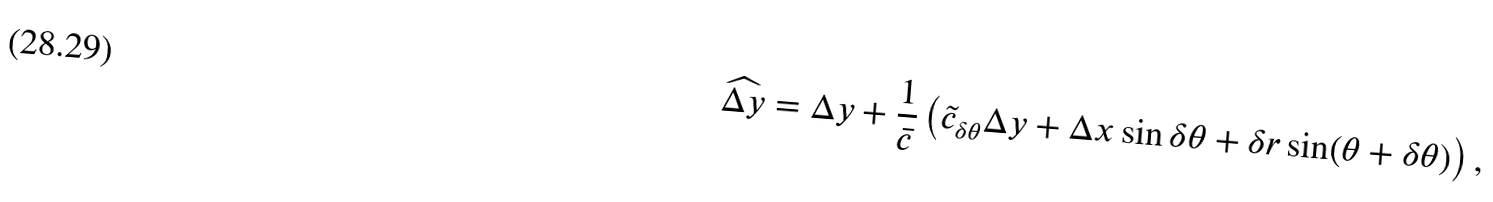Convert formula to latex. <formula><loc_0><loc_0><loc_500><loc_500>\widehat { \Delta y } & = \Delta y + \frac { 1 } { \bar { c } } \left ( \tilde { c } _ { \delta \theta } \Delta y + \Delta x \sin \delta \theta + \delta r \sin ( \theta + \delta \theta ) \right ) ,</formula> 